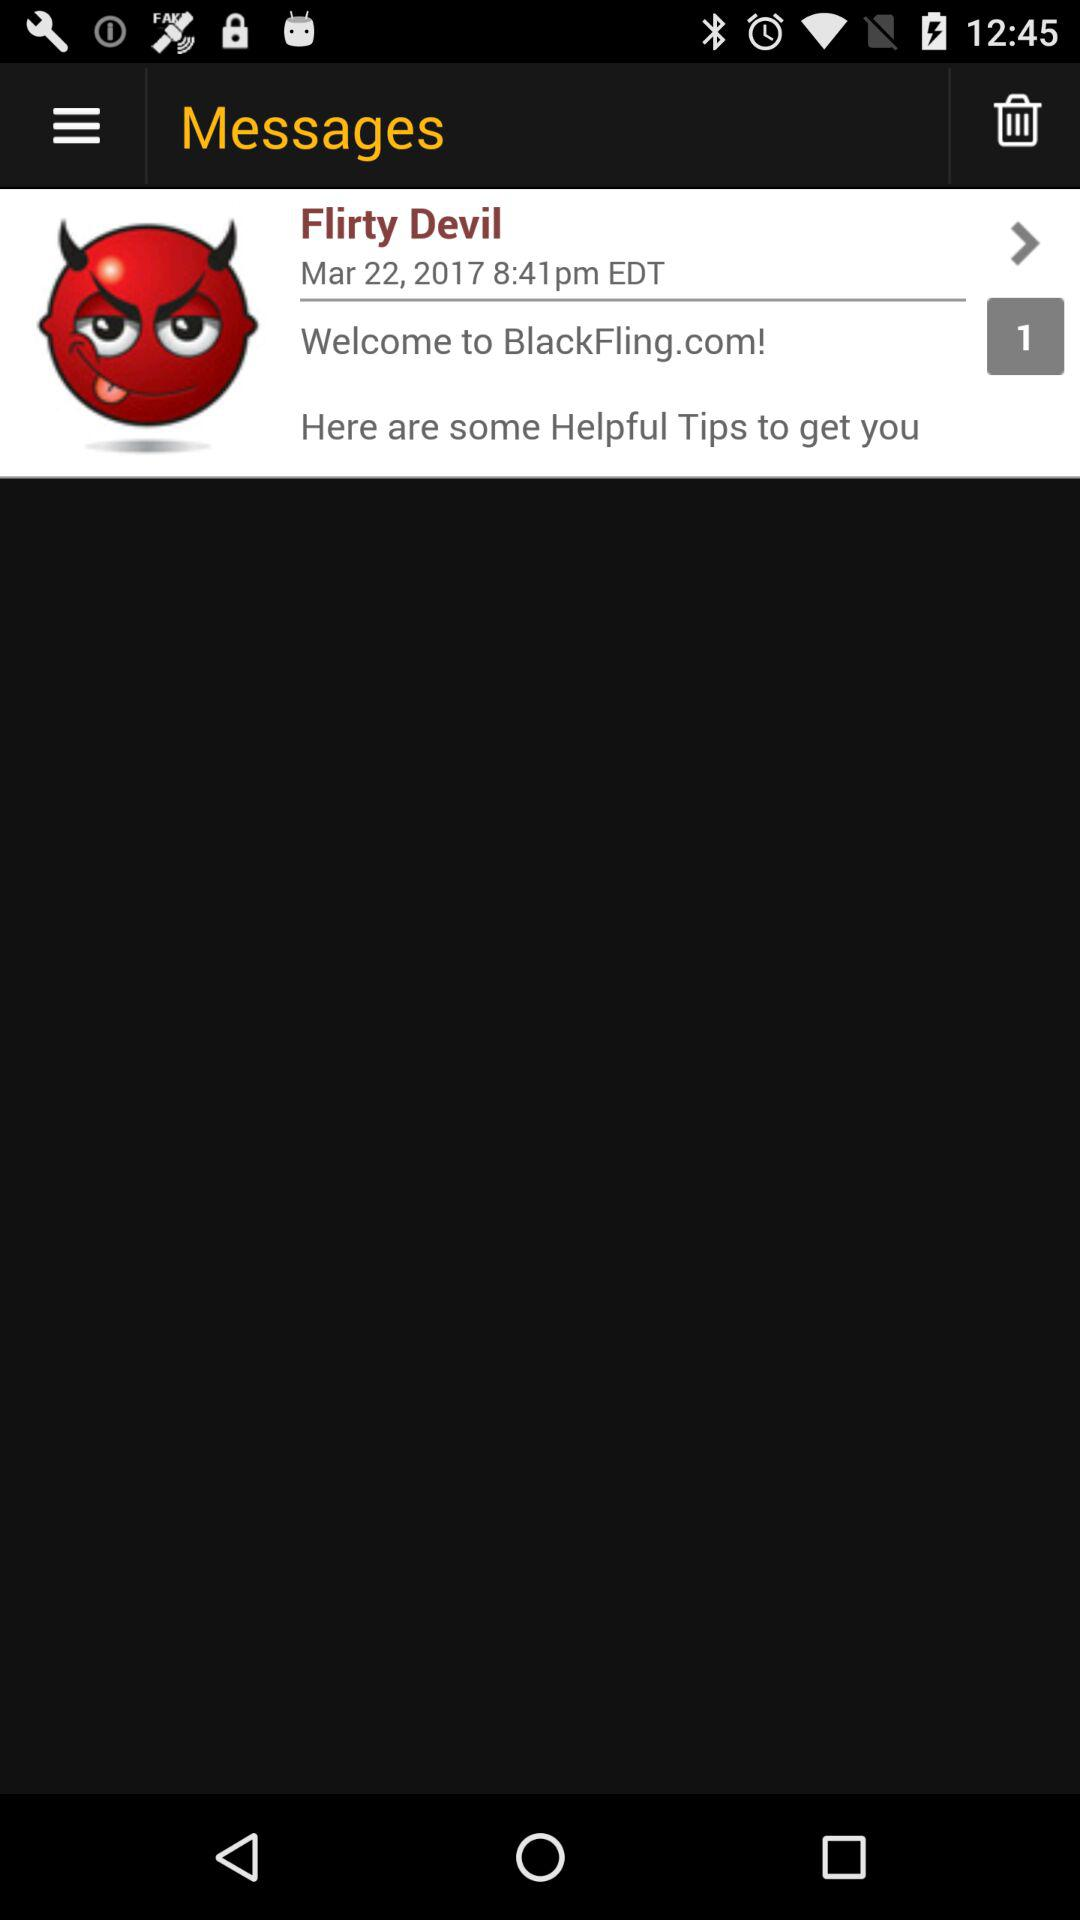What is the mentioned time? The mentioned time is 8:41 p.m. EDT. 